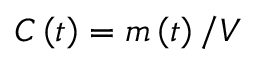Convert formula to latex. <formula><loc_0><loc_0><loc_500><loc_500>C \left ( t \right ) = m \left ( t \right ) / V</formula> 